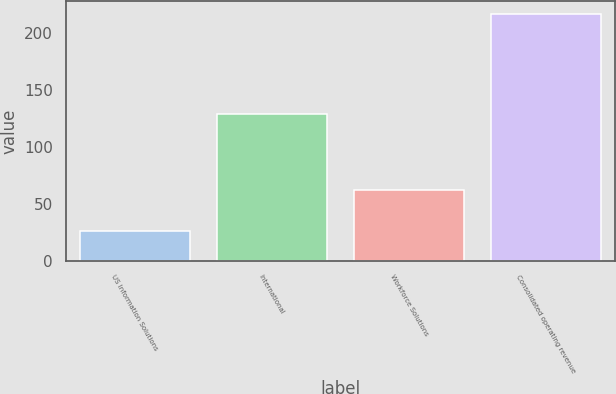Convert chart to OTSL. <chart><loc_0><loc_0><loc_500><loc_500><bar_chart><fcel>US Information Solutions<fcel>International<fcel>Workforce Solutions<fcel>Consolidated operating revenue<nl><fcel>26.2<fcel>128.7<fcel>62<fcel>217.3<nl></chart> 